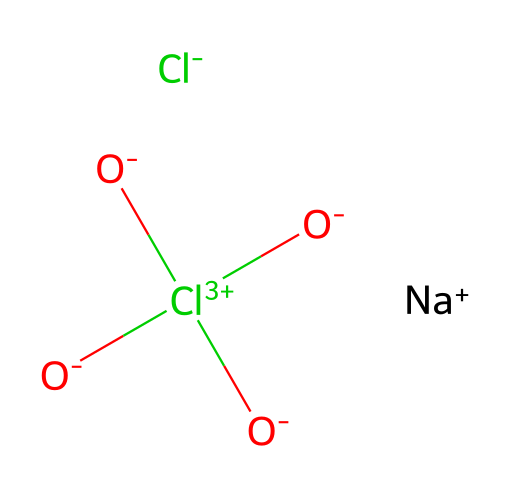how many chlorine atoms are present in this compound? The SMILES representation indicates that there are two chlorine atoms in the molecular structure, represented by "Cl" twice in the sequence.
Answer: two what is the charge of sodium in this compound? The notation "[Na+]" indicates that sodium has a positive charge, denoted by the "+" sign following the Na.
Answer: plus which part of the compound is responsible for disinfection? The presence of "Cl(=O)(=O)=O" indicates a chlorine-based component, specifically chlorate, which is known for its disinfecting properties.
Answer: chlorate what type of bond connects the sodium ion to the chloride ion? The bond between the sodium ion and chloride ion is an ionic bond, which occurs between a metal and a non-metal where electrons are transferred.
Answer: ionic does this compound contain any nitrogen atoms? The SMILES shows no nitrogen atoms present, as there is no representation of "N" in the structure.
Answer: no what functional groups are present in this chemical? The compound contains a chlorate functional group, characterized by chlorine atoms bonded to oxygen atoms double-bonded and single-bonded, as seen in the "Cl(=O)(=O)=O" part.
Answer: chlorate 